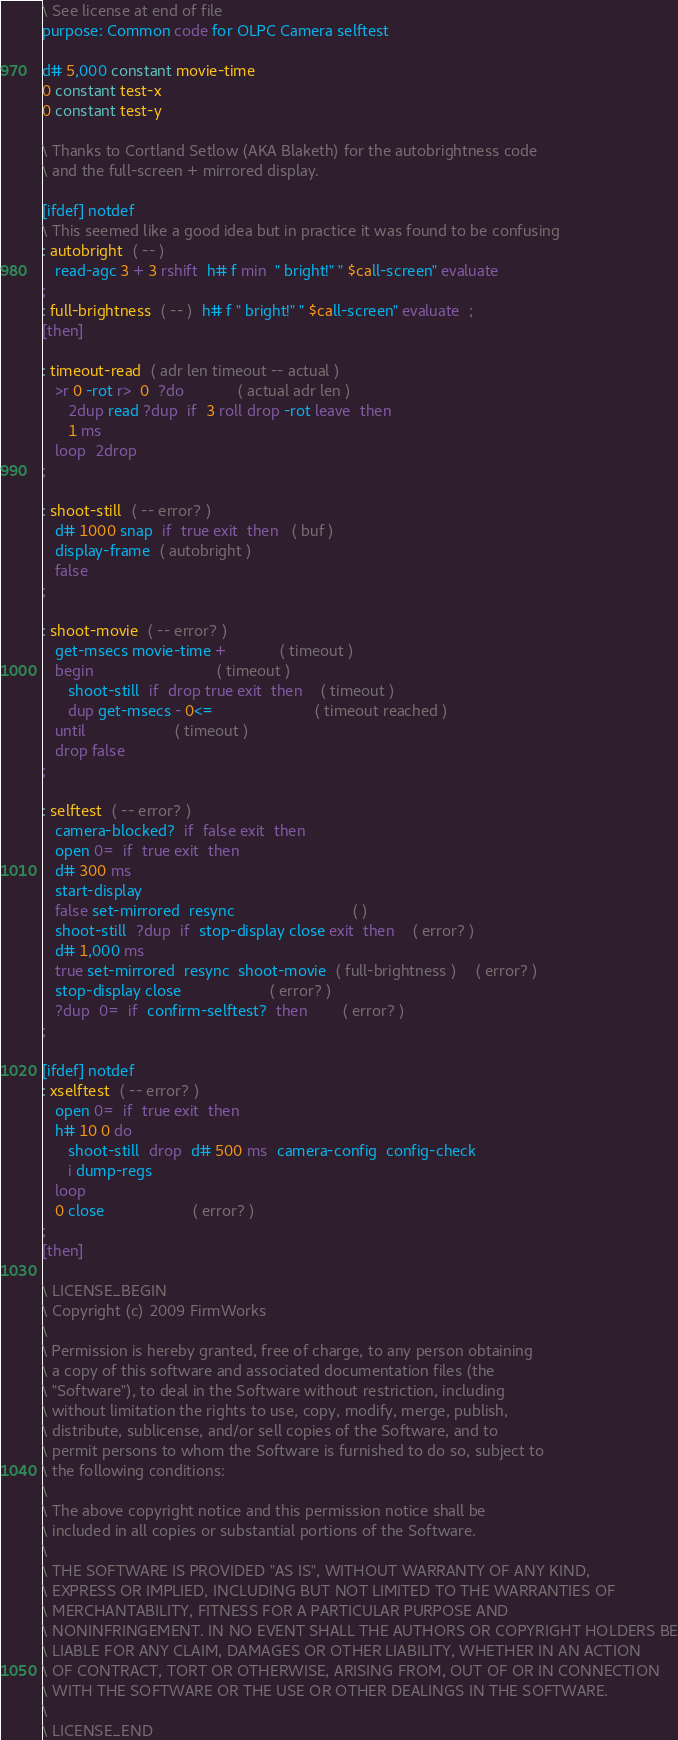<code> <loc_0><loc_0><loc_500><loc_500><_Forth_>\ See license at end of file
purpose: Common code for OLPC Camera selftest

d# 5,000 constant movie-time
0 constant test-x
0 constant test-y

\ Thanks to Cortland Setlow (AKA Blaketh) for the autobrightness code
\ and the full-screen + mirrored display.

[ifdef] notdef
\ This seemed like a good idea but in practice it was found to be confusing
: autobright  ( -- )
   read-agc 3 + 3 rshift  h# f min  " bright!" " $call-screen" evaluate
;
: full-brightness  ( -- )  h# f " bright!" " $call-screen" evaluate  ;
[then]

: timeout-read  ( adr len timeout -- actual )
   >r 0 -rot r>  0  ?do			( actual adr len )
      2dup read ?dup  if  3 roll drop -rot leave  then
      1 ms
   loop  2drop
;

: shoot-still  ( -- error? )
   d# 1000 snap  if  true exit  then   ( buf )
   display-frame  ( autobright )
   false
;

: shoot-movie  ( -- error? )
   get-msecs movie-time +			( timeout )
   begin                 			( timeout )
      shoot-still  if  drop true exit  then 	( timeout )
      dup get-msecs - 0<=                       ( timeout reached )
   until					( timeout )
   drop false
;

: selftest  ( -- error? )
   camera-blocked?  if  false exit  then
   open 0=  if  true exit  then
   d# 300 ms
   start-display
   false set-mirrored  resync                           ( )
   shoot-still  ?dup  if  stop-display close exit  then	( error? )
   d# 1,000 ms
   true set-mirrored  resync  shoot-movie  ( full-brightness )	( error? )
   stop-display close					( error? )
   ?dup  0=  if  confirm-selftest?  then		( error? )
;

[ifdef] notdef
: xselftest  ( -- error? )
   open 0=  if  true exit  then
   h# 10 0 do
      shoot-still  drop  d# 500 ms  camera-config  config-check
      i dump-regs
   loop
   0 close					( error? )
;
[then]

\ LICENSE_BEGIN
\ Copyright (c) 2009 FirmWorks
\ 
\ Permission is hereby granted, free of charge, to any person obtaining
\ a copy of this software and associated documentation files (the
\ "Software"), to deal in the Software without restriction, including
\ without limitation the rights to use, copy, modify, merge, publish,
\ distribute, sublicense, and/or sell copies of the Software, and to
\ permit persons to whom the Software is furnished to do so, subject to
\ the following conditions:
\ 
\ The above copyright notice and this permission notice shall be
\ included in all copies or substantial portions of the Software.
\ 
\ THE SOFTWARE IS PROVIDED "AS IS", WITHOUT WARRANTY OF ANY KIND,
\ EXPRESS OR IMPLIED, INCLUDING BUT NOT LIMITED TO THE WARRANTIES OF
\ MERCHANTABILITY, FITNESS FOR A PARTICULAR PURPOSE AND
\ NONINFRINGEMENT. IN NO EVENT SHALL THE AUTHORS OR COPYRIGHT HOLDERS BE
\ LIABLE FOR ANY CLAIM, DAMAGES OR OTHER LIABILITY, WHETHER IN AN ACTION
\ OF CONTRACT, TORT OR OTHERWISE, ARISING FROM, OUT OF OR IN CONNECTION
\ WITH THE SOFTWARE OR THE USE OR OTHER DEALINGS IN THE SOFTWARE.
\
\ LICENSE_END
</code> 